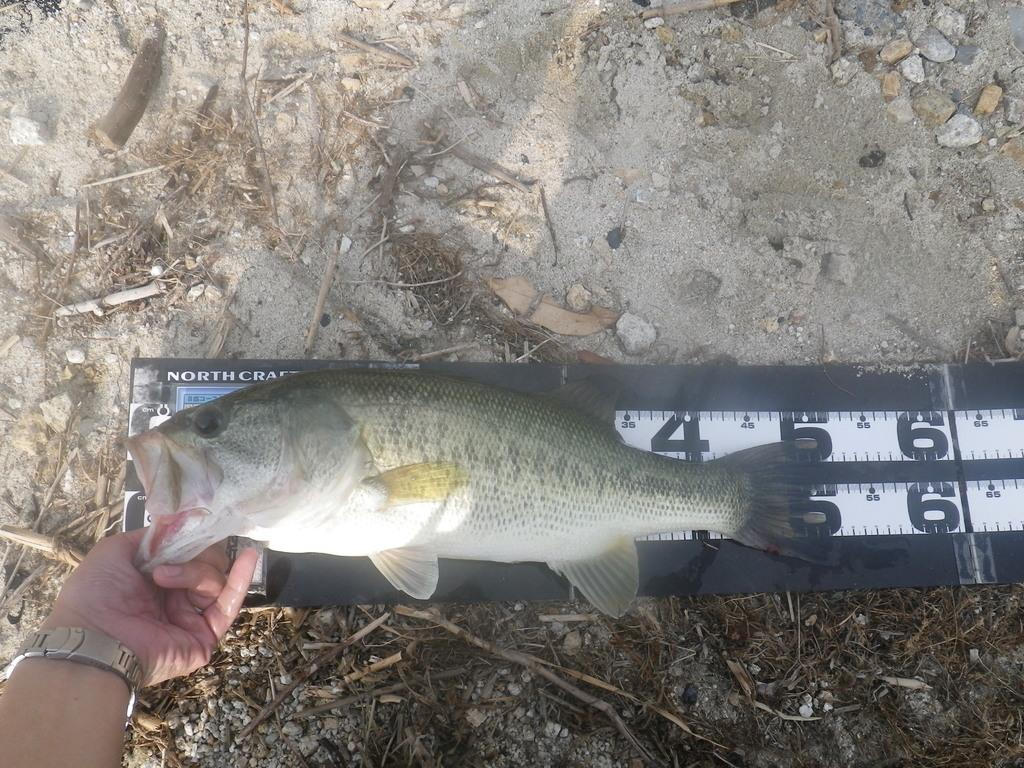What is the person holding in the image? The person is holding a fish in the image. How is the fish being measured or weighed? The fish is on a scale in the image. What type of natural elements can be seen in the image? There are stones, sand, and sticks in the image. What type of wing can be seen on the donkey in the image? There is no donkey or wing present in the image. How many eggs are visible in the image? There are no eggs present in the image. 